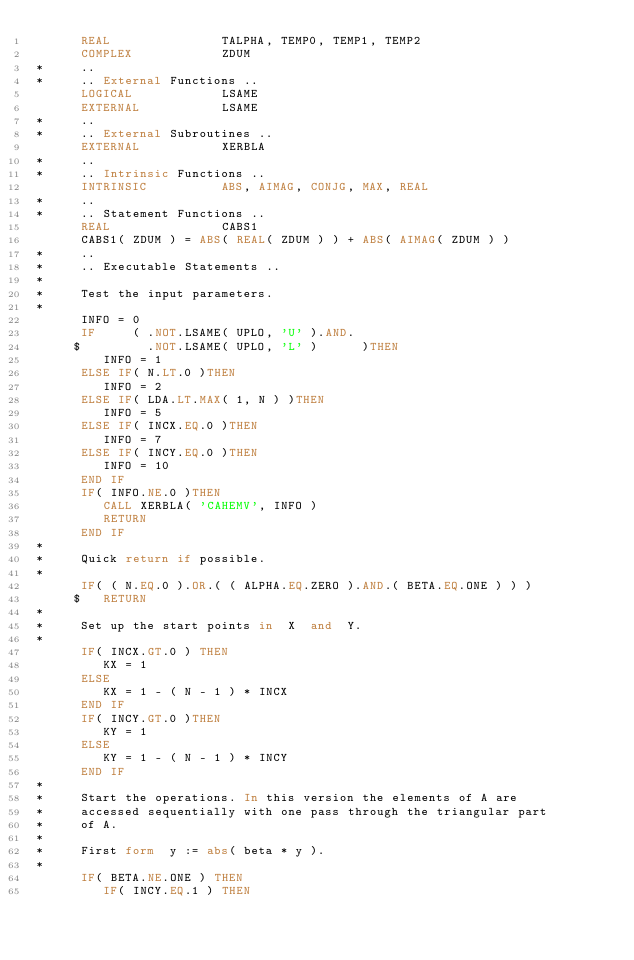<code> <loc_0><loc_0><loc_500><loc_500><_FORTRAN_>      REAL               TALPHA, TEMP0, TEMP1, TEMP2
      COMPLEX            ZDUM
*     ..
*     .. External Functions ..
      LOGICAL            LSAME
      EXTERNAL           LSAME
*     ..
*     .. External Subroutines ..
      EXTERNAL           XERBLA
*     ..
*     .. Intrinsic Functions ..
      INTRINSIC          ABS, AIMAG, CONJG, MAX, REAL
*     ..
*     .. Statement Functions ..
      REAL               CABS1
      CABS1( ZDUM ) = ABS( REAL( ZDUM ) ) + ABS( AIMAG( ZDUM ) )
*     ..
*     .. Executable Statements ..
*
*     Test the input parameters.
*
      INFO = 0
      IF     ( .NOT.LSAME( UPLO, 'U' ).AND.
     $         .NOT.LSAME( UPLO, 'L' )      )THEN
         INFO = 1
      ELSE IF( N.LT.0 )THEN
         INFO = 2
      ELSE IF( LDA.LT.MAX( 1, N ) )THEN
         INFO = 5
      ELSE IF( INCX.EQ.0 )THEN
         INFO = 7
      ELSE IF( INCY.EQ.0 )THEN
         INFO = 10
      END IF
      IF( INFO.NE.0 )THEN
         CALL XERBLA( 'CAHEMV', INFO )
         RETURN
      END IF
*
*     Quick return if possible.
*
      IF( ( N.EQ.0 ).OR.( ( ALPHA.EQ.ZERO ).AND.( BETA.EQ.ONE ) ) )
     $   RETURN
*
*     Set up the start points in  X  and  Y.
*
      IF( INCX.GT.0 ) THEN
         KX = 1
      ELSE
         KX = 1 - ( N - 1 ) * INCX
      END IF
      IF( INCY.GT.0 )THEN
         KY = 1
      ELSE
         KY = 1 - ( N - 1 ) * INCY
      END IF
*
*     Start the operations. In this version the elements of A are
*     accessed sequentially with one pass through the triangular part
*     of A.
*
*     First form  y := abs( beta * y ).
*
      IF( BETA.NE.ONE ) THEN
         IF( INCY.EQ.1 ) THEN</code> 